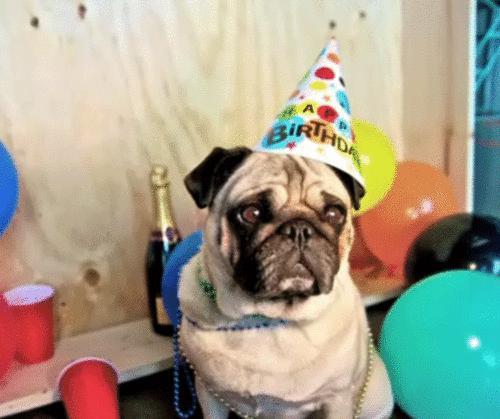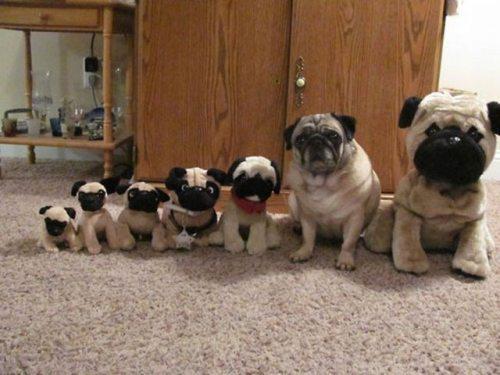The first image is the image on the left, the second image is the image on the right. Assess this claim about the two images: "There are more pug dogs in the right image than in the left.". Correct or not? Answer yes or no. Yes. The first image is the image on the left, the second image is the image on the right. Considering the images on both sides, is "All of the dogs are the same color and none of them are tied on a leash." valid? Answer yes or no. Yes. 